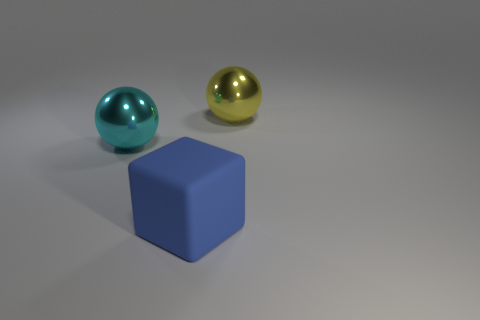Is the big object right of the large blue cube made of the same material as the big object that is in front of the cyan sphere? Though it's difficult to determine the exact material from this image alone, the object to the right of the blue cube appears to have a different texture than the object in front of the cyan sphere. The reflection and color suggest they might be composed of different types of materials. 